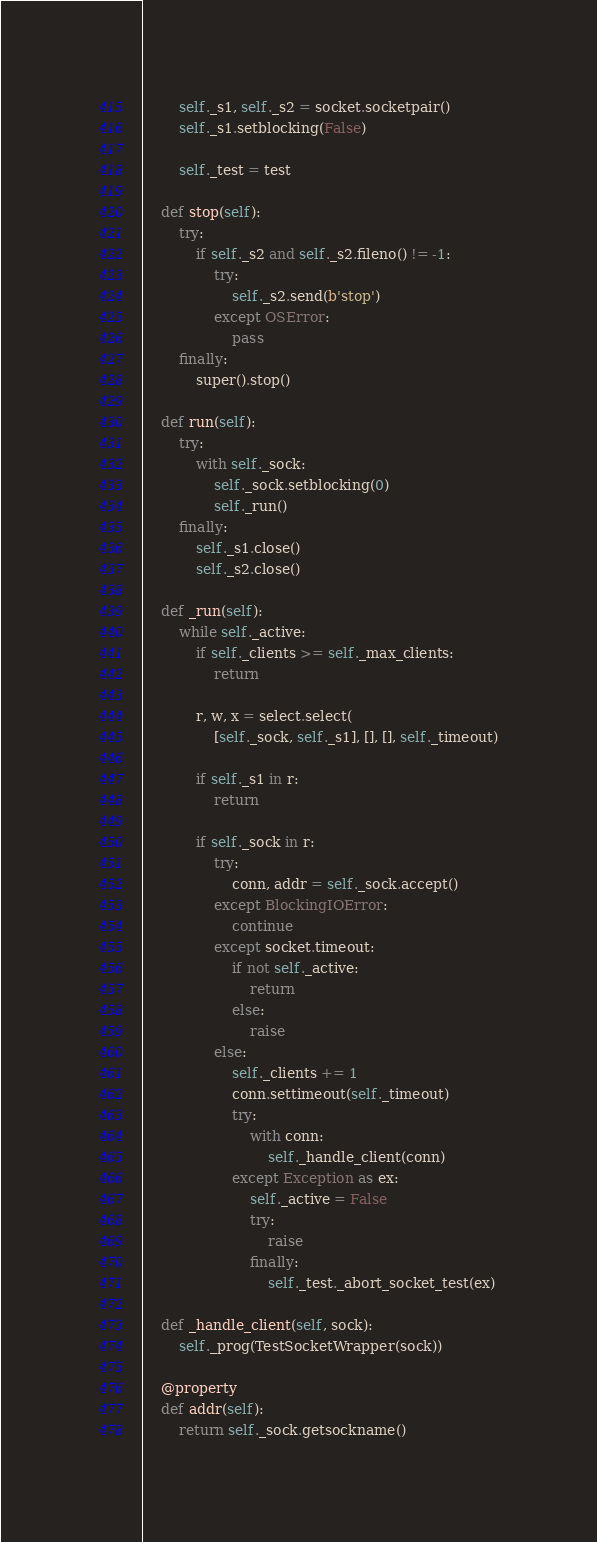Convert code to text. <code><loc_0><loc_0><loc_500><loc_500><_Python_>        self._s1, self._s2 = socket.socketpair()
        self._s1.setblocking(False)

        self._test = test

    def stop(self):
        try:
            if self._s2 and self._s2.fileno() != -1:
                try:
                    self._s2.send(b'stop')
                except OSError:
                    pass
        finally:
            super().stop()

    def run(self):
        try:
            with self._sock:
                self._sock.setblocking(0)
                self._run()
        finally:
            self._s1.close()
            self._s2.close()

    def _run(self):
        while self._active:
            if self._clients >= self._max_clients:
                return

            r, w, x = select.select(
                [self._sock, self._s1], [], [], self._timeout)

            if self._s1 in r:
                return

            if self._sock in r:
                try:
                    conn, addr = self._sock.accept()
                except BlockingIOError:
                    continue
                except socket.timeout:
                    if not self._active:
                        return
                    else:
                        raise
                else:
                    self._clients += 1
                    conn.settimeout(self._timeout)
                    try:
                        with conn:
                            self._handle_client(conn)
                    except Exception as ex:
                        self._active = False
                        try:
                            raise
                        finally:
                            self._test._abort_socket_test(ex)

    def _handle_client(self, sock):
        self._prog(TestSocketWrapper(sock))

    @property
    def addr(self):
        return self._sock.getsockname()
</code> 